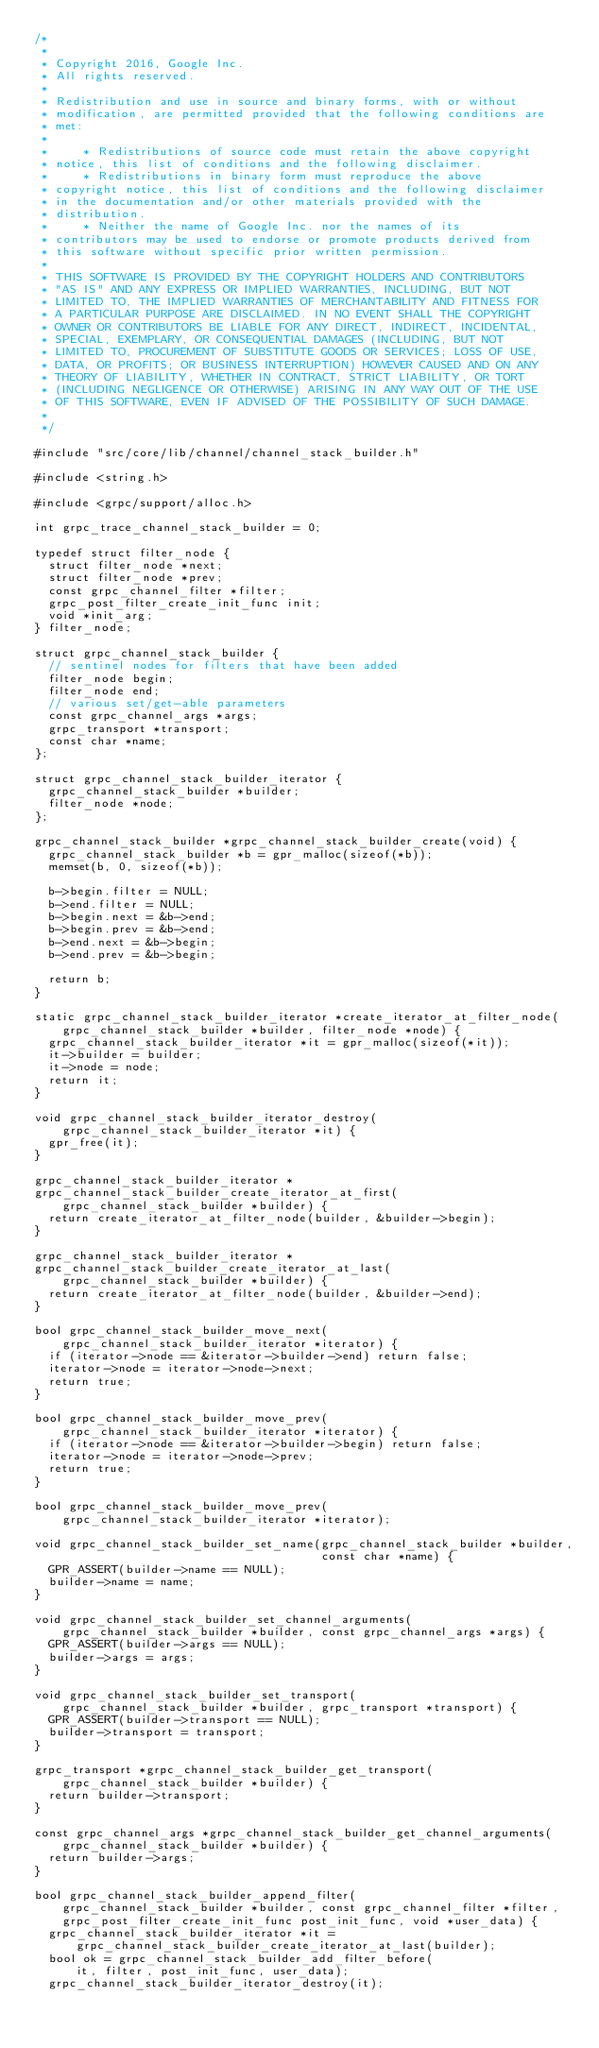<code> <loc_0><loc_0><loc_500><loc_500><_C_>/*
 *
 * Copyright 2016, Google Inc.
 * All rights reserved.
 *
 * Redistribution and use in source and binary forms, with or without
 * modification, are permitted provided that the following conditions are
 * met:
 *
 *     * Redistributions of source code must retain the above copyright
 * notice, this list of conditions and the following disclaimer.
 *     * Redistributions in binary form must reproduce the above
 * copyright notice, this list of conditions and the following disclaimer
 * in the documentation and/or other materials provided with the
 * distribution.
 *     * Neither the name of Google Inc. nor the names of its
 * contributors may be used to endorse or promote products derived from
 * this software without specific prior written permission.
 *
 * THIS SOFTWARE IS PROVIDED BY THE COPYRIGHT HOLDERS AND CONTRIBUTORS
 * "AS IS" AND ANY EXPRESS OR IMPLIED WARRANTIES, INCLUDING, BUT NOT
 * LIMITED TO, THE IMPLIED WARRANTIES OF MERCHANTABILITY AND FITNESS FOR
 * A PARTICULAR PURPOSE ARE DISCLAIMED. IN NO EVENT SHALL THE COPYRIGHT
 * OWNER OR CONTRIBUTORS BE LIABLE FOR ANY DIRECT, INDIRECT, INCIDENTAL,
 * SPECIAL, EXEMPLARY, OR CONSEQUENTIAL DAMAGES (INCLUDING, BUT NOT
 * LIMITED TO, PROCUREMENT OF SUBSTITUTE GOODS OR SERVICES; LOSS OF USE,
 * DATA, OR PROFITS; OR BUSINESS INTERRUPTION) HOWEVER CAUSED AND ON ANY
 * THEORY OF LIABILITY, WHETHER IN CONTRACT, STRICT LIABILITY, OR TORT
 * (INCLUDING NEGLIGENCE OR OTHERWISE) ARISING IN ANY WAY OUT OF THE USE
 * OF THIS SOFTWARE, EVEN IF ADVISED OF THE POSSIBILITY OF SUCH DAMAGE.
 *
 */

#include "src/core/lib/channel/channel_stack_builder.h"

#include <string.h>

#include <grpc/support/alloc.h>

int grpc_trace_channel_stack_builder = 0;

typedef struct filter_node {
  struct filter_node *next;
  struct filter_node *prev;
  const grpc_channel_filter *filter;
  grpc_post_filter_create_init_func init;
  void *init_arg;
} filter_node;

struct grpc_channel_stack_builder {
  // sentinel nodes for filters that have been added
  filter_node begin;
  filter_node end;
  // various set/get-able parameters
  const grpc_channel_args *args;
  grpc_transport *transport;
  const char *name;
};

struct grpc_channel_stack_builder_iterator {
  grpc_channel_stack_builder *builder;
  filter_node *node;
};

grpc_channel_stack_builder *grpc_channel_stack_builder_create(void) {
  grpc_channel_stack_builder *b = gpr_malloc(sizeof(*b));
  memset(b, 0, sizeof(*b));

  b->begin.filter = NULL;
  b->end.filter = NULL;
  b->begin.next = &b->end;
  b->begin.prev = &b->end;
  b->end.next = &b->begin;
  b->end.prev = &b->begin;

  return b;
}

static grpc_channel_stack_builder_iterator *create_iterator_at_filter_node(
    grpc_channel_stack_builder *builder, filter_node *node) {
  grpc_channel_stack_builder_iterator *it = gpr_malloc(sizeof(*it));
  it->builder = builder;
  it->node = node;
  return it;
}

void grpc_channel_stack_builder_iterator_destroy(
    grpc_channel_stack_builder_iterator *it) {
  gpr_free(it);
}

grpc_channel_stack_builder_iterator *
grpc_channel_stack_builder_create_iterator_at_first(
    grpc_channel_stack_builder *builder) {
  return create_iterator_at_filter_node(builder, &builder->begin);
}

grpc_channel_stack_builder_iterator *
grpc_channel_stack_builder_create_iterator_at_last(
    grpc_channel_stack_builder *builder) {
  return create_iterator_at_filter_node(builder, &builder->end);
}

bool grpc_channel_stack_builder_move_next(
    grpc_channel_stack_builder_iterator *iterator) {
  if (iterator->node == &iterator->builder->end) return false;
  iterator->node = iterator->node->next;
  return true;
}

bool grpc_channel_stack_builder_move_prev(
    grpc_channel_stack_builder_iterator *iterator) {
  if (iterator->node == &iterator->builder->begin) return false;
  iterator->node = iterator->node->prev;
  return true;
}

bool grpc_channel_stack_builder_move_prev(
    grpc_channel_stack_builder_iterator *iterator);

void grpc_channel_stack_builder_set_name(grpc_channel_stack_builder *builder,
                                         const char *name) {
  GPR_ASSERT(builder->name == NULL);
  builder->name = name;
}

void grpc_channel_stack_builder_set_channel_arguments(
    grpc_channel_stack_builder *builder, const grpc_channel_args *args) {
  GPR_ASSERT(builder->args == NULL);
  builder->args = args;
}

void grpc_channel_stack_builder_set_transport(
    grpc_channel_stack_builder *builder, grpc_transport *transport) {
  GPR_ASSERT(builder->transport == NULL);
  builder->transport = transport;
}

grpc_transport *grpc_channel_stack_builder_get_transport(
    grpc_channel_stack_builder *builder) {
  return builder->transport;
}

const grpc_channel_args *grpc_channel_stack_builder_get_channel_arguments(
    grpc_channel_stack_builder *builder) {
  return builder->args;
}

bool grpc_channel_stack_builder_append_filter(
    grpc_channel_stack_builder *builder, const grpc_channel_filter *filter,
    grpc_post_filter_create_init_func post_init_func, void *user_data) {
  grpc_channel_stack_builder_iterator *it =
      grpc_channel_stack_builder_create_iterator_at_last(builder);
  bool ok = grpc_channel_stack_builder_add_filter_before(
      it, filter, post_init_func, user_data);
  grpc_channel_stack_builder_iterator_destroy(it);</code> 